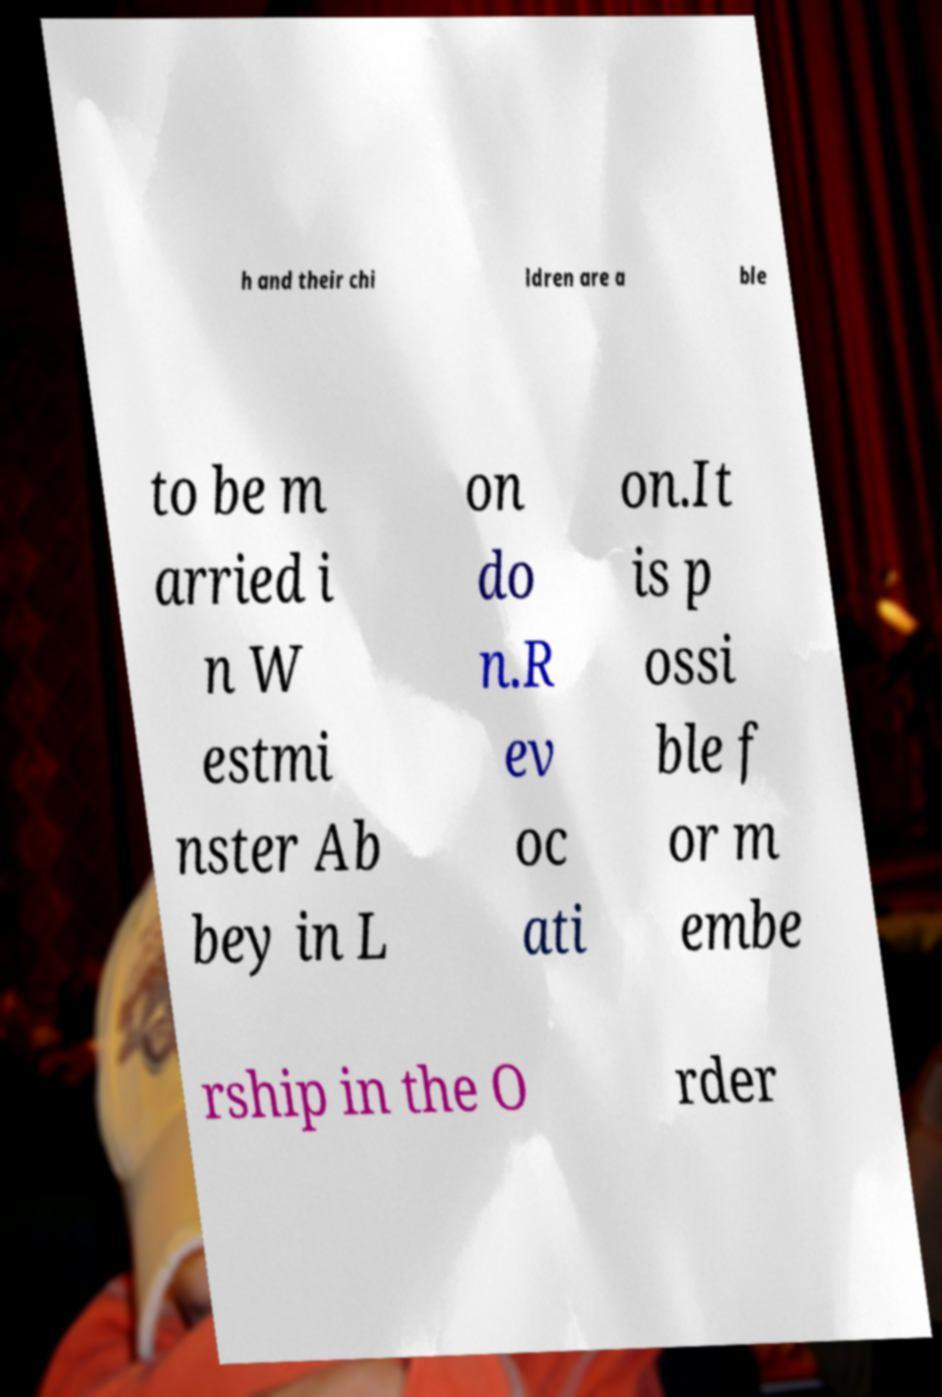Could you extract and type out the text from this image? h and their chi ldren are a ble to be m arried i n W estmi nster Ab bey in L on do n.R ev oc ati on.It is p ossi ble f or m embe rship in the O rder 